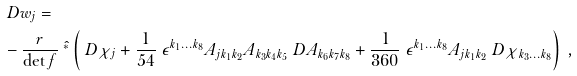<formula> <loc_0><loc_0><loc_500><loc_500>& \ D w _ { j } = \\ & - \frac { r } { \det f } \ \hat { ^ { * } } \left ( \ D \chi _ { j } + \frac { 1 } { 5 4 } \ \epsilon ^ { k _ { 1 } \dots k _ { 8 } } A _ { j k _ { 1 } k _ { 2 } } A _ { k _ { 3 } k _ { 4 } k _ { 5 } } \ D A _ { k _ { 6 } k _ { 7 } k _ { 8 } } + \frac { 1 } { 3 6 0 } \ \epsilon ^ { k _ { 1 } \dots k _ { 8 } } A _ { j k _ { 1 } k _ { 2 } } \ D \chi _ { k _ { 3 } \dots k _ { 8 } } \right ) \ ,</formula> 